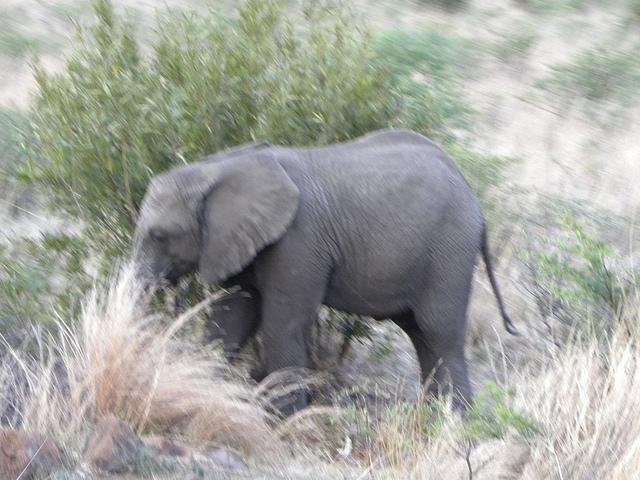Does the elephants tail touch the ground?
Concise answer only. No. Which animal is this?
Keep it brief. Elephant. What is the most significant trait of this animal?
Give a very brief answer. Trunk. What is the elephant standing under?
Concise answer only. Bush. 